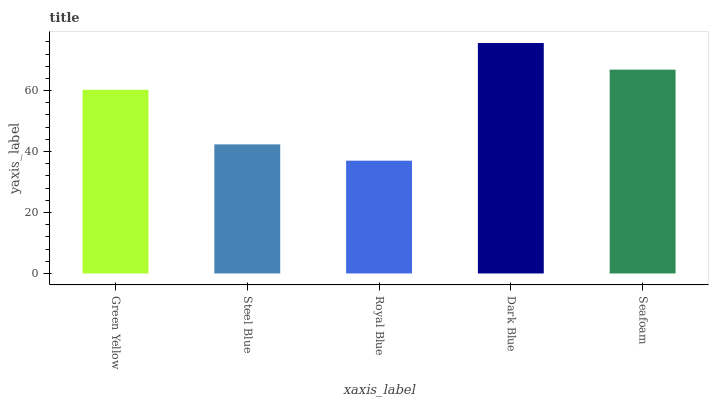Is Steel Blue the minimum?
Answer yes or no. No. Is Steel Blue the maximum?
Answer yes or no. No. Is Green Yellow greater than Steel Blue?
Answer yes or no. Yes. Is Steel Blue less than Green Yellow?
Answer yes or no. Yes. Is Steel Blue greater than Green Yellow?
Answer yes or no. No. Is Green Yellow less than Steel Blue?
Answer yes or no. No. Is Green Yellow the high median?
Answer yes or no. Yes. Is Green Yellow the low median?
Answer yes or no. Yes. Is Royal Blue the high median?
Answer yes or no. No. Is Royal Blue the low median?
Answer yes or no. No. 